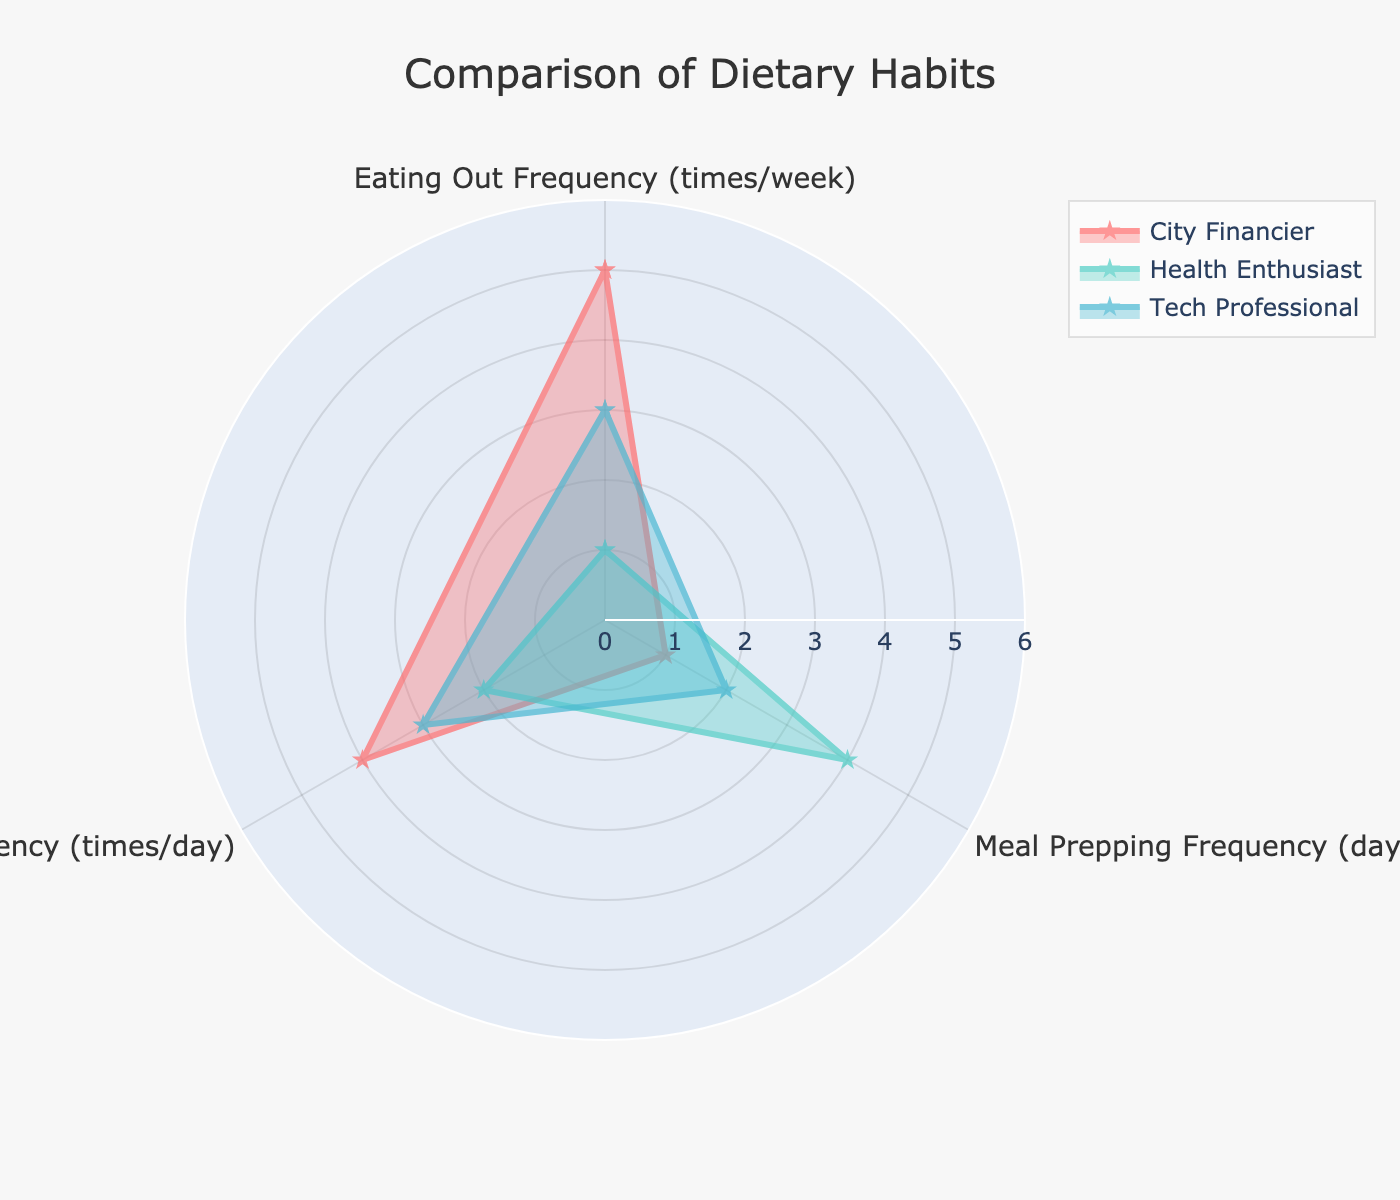Which group eats out the most frequently? Look at the "Eating Out Frequency" category. The City Financier has the highest value at 5 times per week.
Answer: City Financier How often does the Health Enthusiast meal prep per week? Refer to the "Meal Prepping Frequency" category. The Health Enthusiast meal preps 4 days per week.
Answer: 4 days per week Who snacks more frequently, the City Financier or the Tech Professional? Compare the "Snacking Frequency" values for both groups. The City Financier snacks 4 times per day, while the Tech Professional snacks 3 times per day.
Answer: City Financier Which group has the lowest frequency for eating out? Refer to the "Eating Out Frequency" category. The Health Enthusiast has the lowest value at 1 time per week.
Answer: Health Enthusiast What is the sum of snacking frequency for all groups? Add the values for each group's "Snacking Frequency": City Financier (4) + Health Enthusiast (2) + Tech Professional (3).
Answer: 9 times per day Which categories show the greatest difference between the City Financier and the Health Enthusiast? Assess each category for the differences between their values. "Eating Out Frequency" has the greatest difference of 4 (5 - 1).
Answer: Eating Out Frequency What is the average meal prepping frequency across all groups? Add the "Meal Prepping Frequency" values and divide by the number of groups: (1 + 4 + 2) / 3.
Answer: 2.33 days per week Compare the meal prepping frequency of the City Financier to the Tech Professional. Who is higher? Look at the "Meal Prepping Frequency" category. The Tech Professional meal preps 2 days per week, while the City Financier meal preps only 1 day per week.
Answer: Tech Professional In which category do all groups score exactly the same? Check for matching values across all groups in each category. There is no category where all groups have the same score.
Answer: None What is the range of values for snacking frequency across all groups? Identify the minimum and maximum values in the "Snacking Frequency" category: the minimum is 2 (Health Enthusiast) and the maximum is 4 (City Financier). The range is 4 - 2.
Answer: 2 